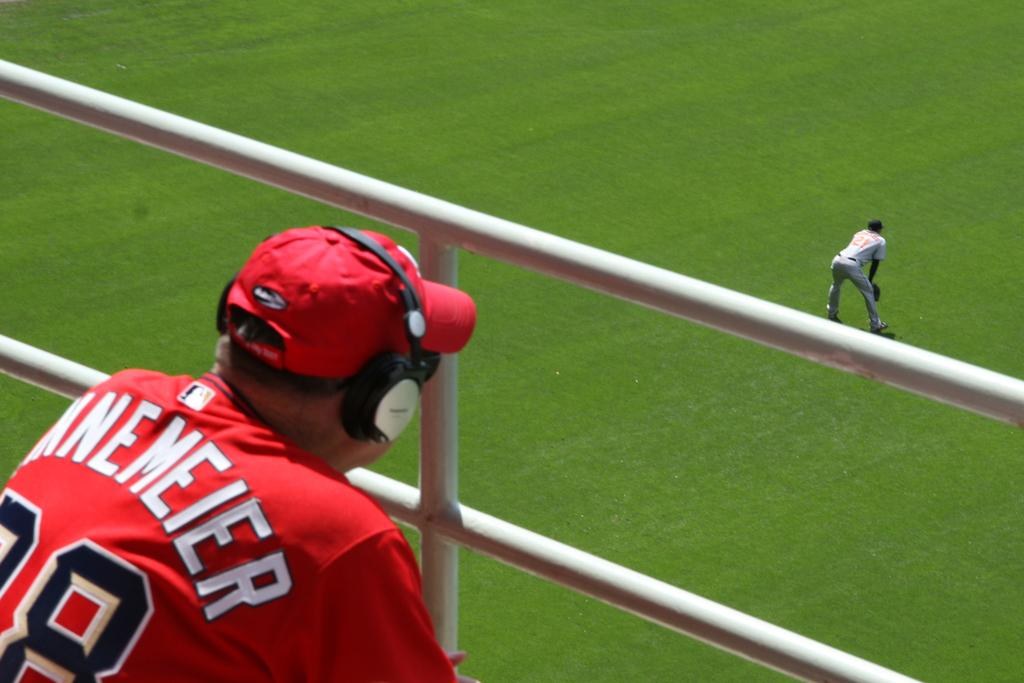How many people are in the image? There are persons standing in the image. What type of surface can be seen beneath the people? There is ground visible in the image. What objects are present in the image that might be used for security or containment? Iron bars are present in the image. What type of tin can be seen in the image? There is no tin present in the image. Is there a scarecrow visible in the image? There is no scarecrow present in the image. 